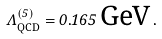<formula> <loc_0><loc_0><loc_500><loc_500>\Lambda _ { \text {QCD} } ^ { ( 5 ) } = 0 . 1 6 5 \, \text {GeV} \, .</formula> 